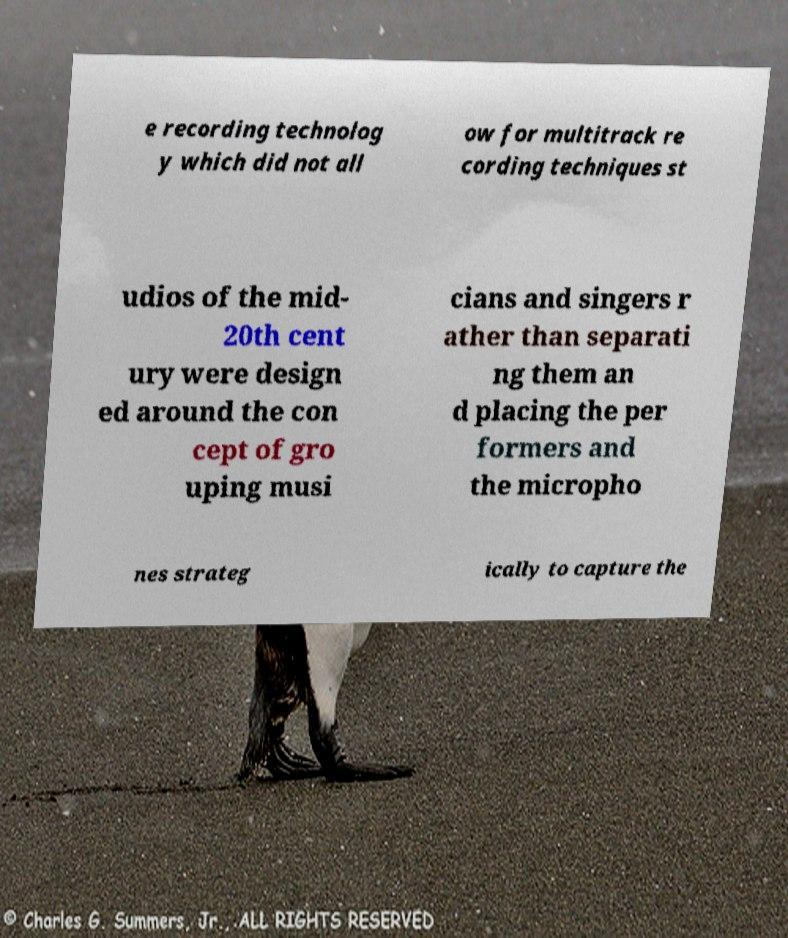Can you accurately transcribe the text from the provided image for me? e recording technolog y which did not all ow for multitrack re cording techniques st udios of the mid- 20th cent ury were design ed around the con cept of gro uping musi cians and singers r ather than separati ng them an d placing the per formers and the micropho nes strateg ically to capture the 